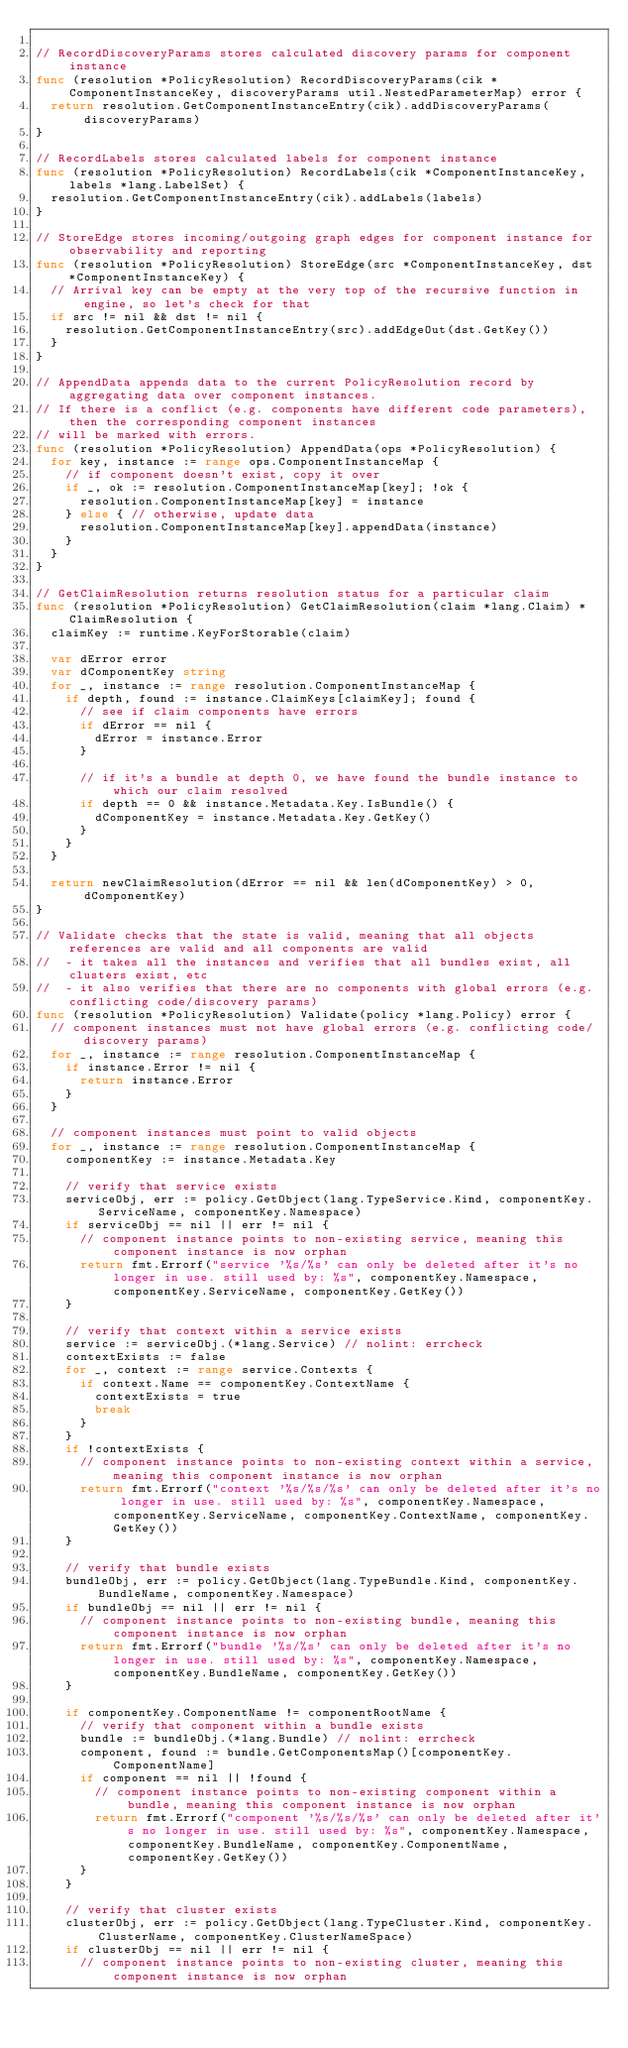Convert code to text. <code><loc_0><loc_0><loc_500><loc_500><_Go_>
// RecordDiscoveryParams stores calculated discovery params for component instance
func (resolution *PolicyResolution) RecordDiscoveryParams(cik *ComponentInstanceKey, discoveryParams util.NestedParameterMap) error {
	return resolution.GetComponentInstanceEntry(cik).addDiscoveryParams(discoveryParams)
}

// RecordLabels stores calculated labels for component instance
func (resolution *PolicyResolution) RecordLabels(cik *ComponentInstanceKey, labels *lang.LabelSet) {
	resolution.GetComponentInstanceEntry(cik).addLabels(labels)
}

// StoreEdge stores incoming/outgoing graph edges for component instance for observability and reporting
func (resolution *PolicyResolution) StoreEdge(src *ComponentInstanceKey, dst *ComponentInstanceKey) {
	// Arrival key can be empty at the very top of the recursive function in engine, so let's check for that
	if src != nil && dst != nil {
		resolution.GetComponentInstanceEntry(src).addEdgeOut(dst.GetKey())
	}
}

// AppendData appends data to the current PolicyResolution record by aggregating data over component instances.
// If there is a conflict (e.g. components have different code parameters), then the corresponding component instances
// will be marked with errors.
func (resolution *PolicyResolution) AppendData(ops *PolicyResolution) {
	for key, instance := range ops.ComponentInstanceMap {
		// if component doesn't exist, copy it over
		if _, ok := resolution.ComponentInstanceMap[key]; !ok {
			resolution.ComponentInstanceMap[key] = instance
		} else { // otherwise, update data
			resolution.ComponentInstanceMap[key].appendData(instance)
		}
	}
}

// GetClaimResolution returns resolution status for a particular claim
func (resolution *PolicyResolution) GetClaimResolution(claim *lang.Claim) *ClaimResolution {
	claimKey := runtime.KeyForStorable(claim)

	var dError error
	var dComponentKey string
	for _, instance := range resolution.ComponentInstanceMap {
		if depth, found := instance.ClaimKeys[claimKey]; found {
			// see if claim components have errors
			if dError == nil {
				dError = instance.Error
			}

			// if it's a bundle at depth 0, we have found the bundle instance to which our claim resolved
			if depth == 0 && instance.Metadata.Key.IsBundle() {
				dComponentKey = instance.Metadata.Key.GetKey()
			}
		}
	}

	return newClaimResolution(dError == nil && len(dComponentKey) > 0, dComponentKey)
}

// Validate checks that the state is valid, meaning that all objects references are valid and all components are valid
//  - it takes all the instances and verifies that all bundles exist, all clusters exist, etc
//  - it also verifies that there are no components with global errors (e.g. conflicting code/discovery params)
func (resolution *PolicyResolution) Validate(policy *lang.Policy) error {
	// component instances must not have global errors (e.g. conflicting code/discovery params)
	for _, instance := range resolution.ComponentInstanceMap {
		if instance.Error != nil {
			return instance.Error
		}
	}

	// component instances must point to valid objects
	for _, instance := range resolution.ComponentInstanceMap {
		componentKey := instance.Metadata.Key

		// verify that service exists
		serviceObj, err := policy.GetObject(lang.TypeService.Kind, componentKey.ServiceName, componentKey.Namespace)
		if serviceObj == nil || err != nil {
			// component instance points to non-existing service, meaning this component instance is now orphan
			return fmt.Errorf("service '%s/%s' can only be deleted after it's no longer in use. still used by: %s", componentKey.Namespace, componentKey.ServiceName, componentKey.GetKey())
		}

		// verify that context within a service exists
		service := serviceObj.(*lang.Service) // nolint: errcheck
		contextExists := false
		for _, context := range service.Contexts {
			if context.Name == componentKey.ContextName {
				contextExists = true
				break
			}
		}
		if !contextExists {
			// component instance points to non-existing context within a service, meaning this component instance is now orphan
			return fmt.Errorf("context '%s/%s/%s' can only be deleted after it's no longer in use. still used by: %s", componentKey.Namespace, componentKey.ServiceName, componentKey.ContextName, componentKey.GetKey())
		}

		// verify that bundle exists
		bundleObj, err := policy.GetObject(lang.TypeBundle.Kind, componentKey.BundleName, componentKey.Namespace)
		if bundleObj == nil || err != nil {
			// component instance points to non-existing bundle, meaning this component instance is now orphan
			return fmt.Errorf("bundle '%s/%s' can only be deleted after it's no longer in use. still used by: %s", componentKey.Namespace, componentKey.BundleName, componentKey.GetKey())
		}

		if componentKey.ComponentName != componentRootName {
			// verify that component within a bundle exists
			bundle := bundleObj.(*lang.Bundle) // nolint: errcheck
			component, found := bundle.GetComponentsMap()[componentKey.ComponentName]
			if component == nil || !found {
				// component instance points to non-existing component within a bundle, meaning this component instance is now orphan
				return fmt.Errorf("component '%s/%s/%s' can only be deleted after it's no longer in use. still used by: %s", componentKey.Namespace, componentKey.BundleName, componentKey.ComponentName, componentKey.GetKey())
			}
		}

		// verify that cluster exists
		clusterObj, err := policy.GetObject(lang.TypeCluster.Kind, componentKey.ClusterName, componentKey.ClusterNameSpace)
		if clusterObj == nil || err != nil {
			// component instance points to non-existing cluster, meaning this component instance is now orphan</code> 